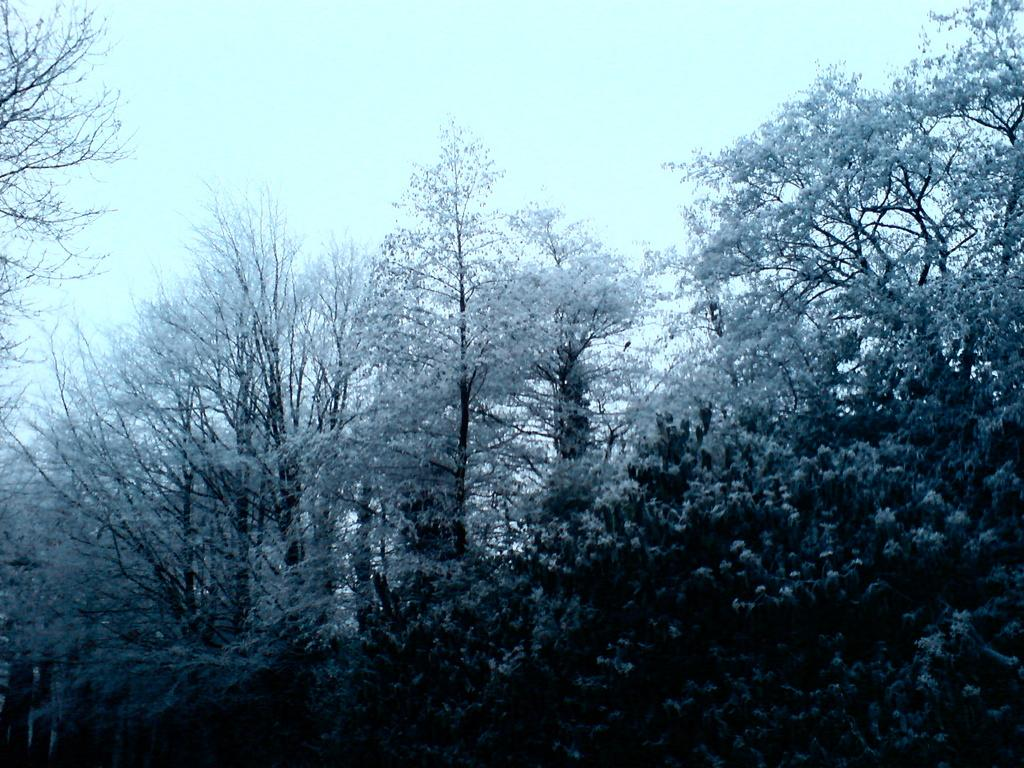What type of plants can be seen in the image? There are plants with flowers in the image. What other vegetation is present in the image? There are trees in the image. What part of the natural environment is visible in the image? The sky is visible in the image. How many experts are present in the image? There are no experts present in the image; it features plants, trees, and the sky. What type of heart can be seen in the image? There is no heart present in the image; it features plants, trees, and the sky. 